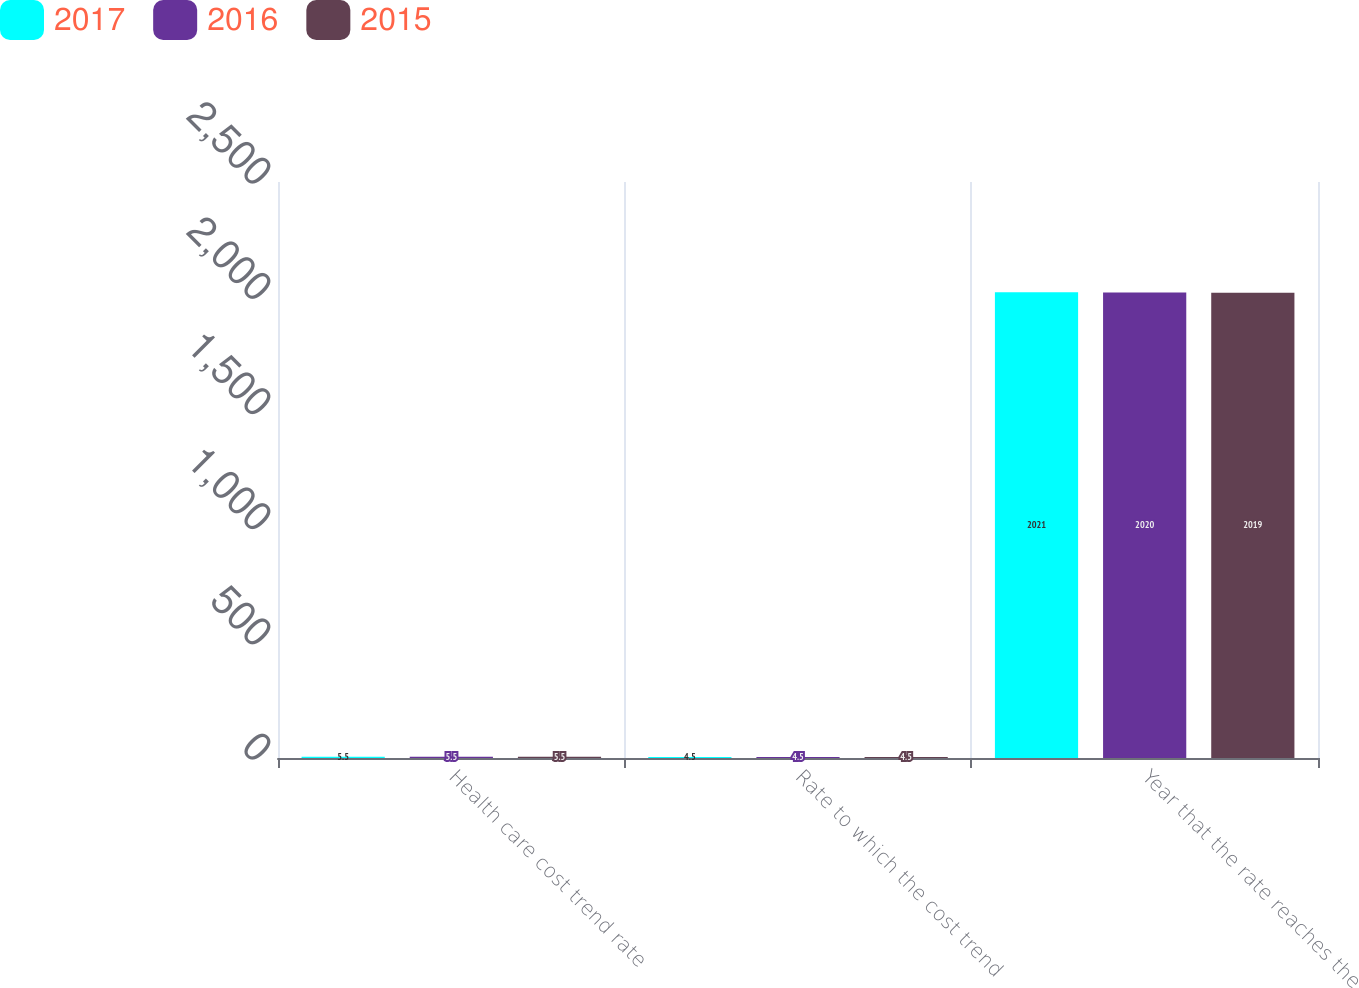Convert chart. <chart><loc_0><loc_0><loc_500><loc_500><stacked_bar_chart><ecel><fcel>Health care cost trend rate<fcel>Rate to which the cost trend<fcel>Year that the rate reaches the<nl><fcel>2017<fcel>5.5<fcel>4.5<fcel>2021<nl><fcel>2016<fcel>5.5<fcel>4.5<fcel>2020<nl><fcel>2015<fcel>5.5<fcel>4.5<fcel>2019<nl></chart> 